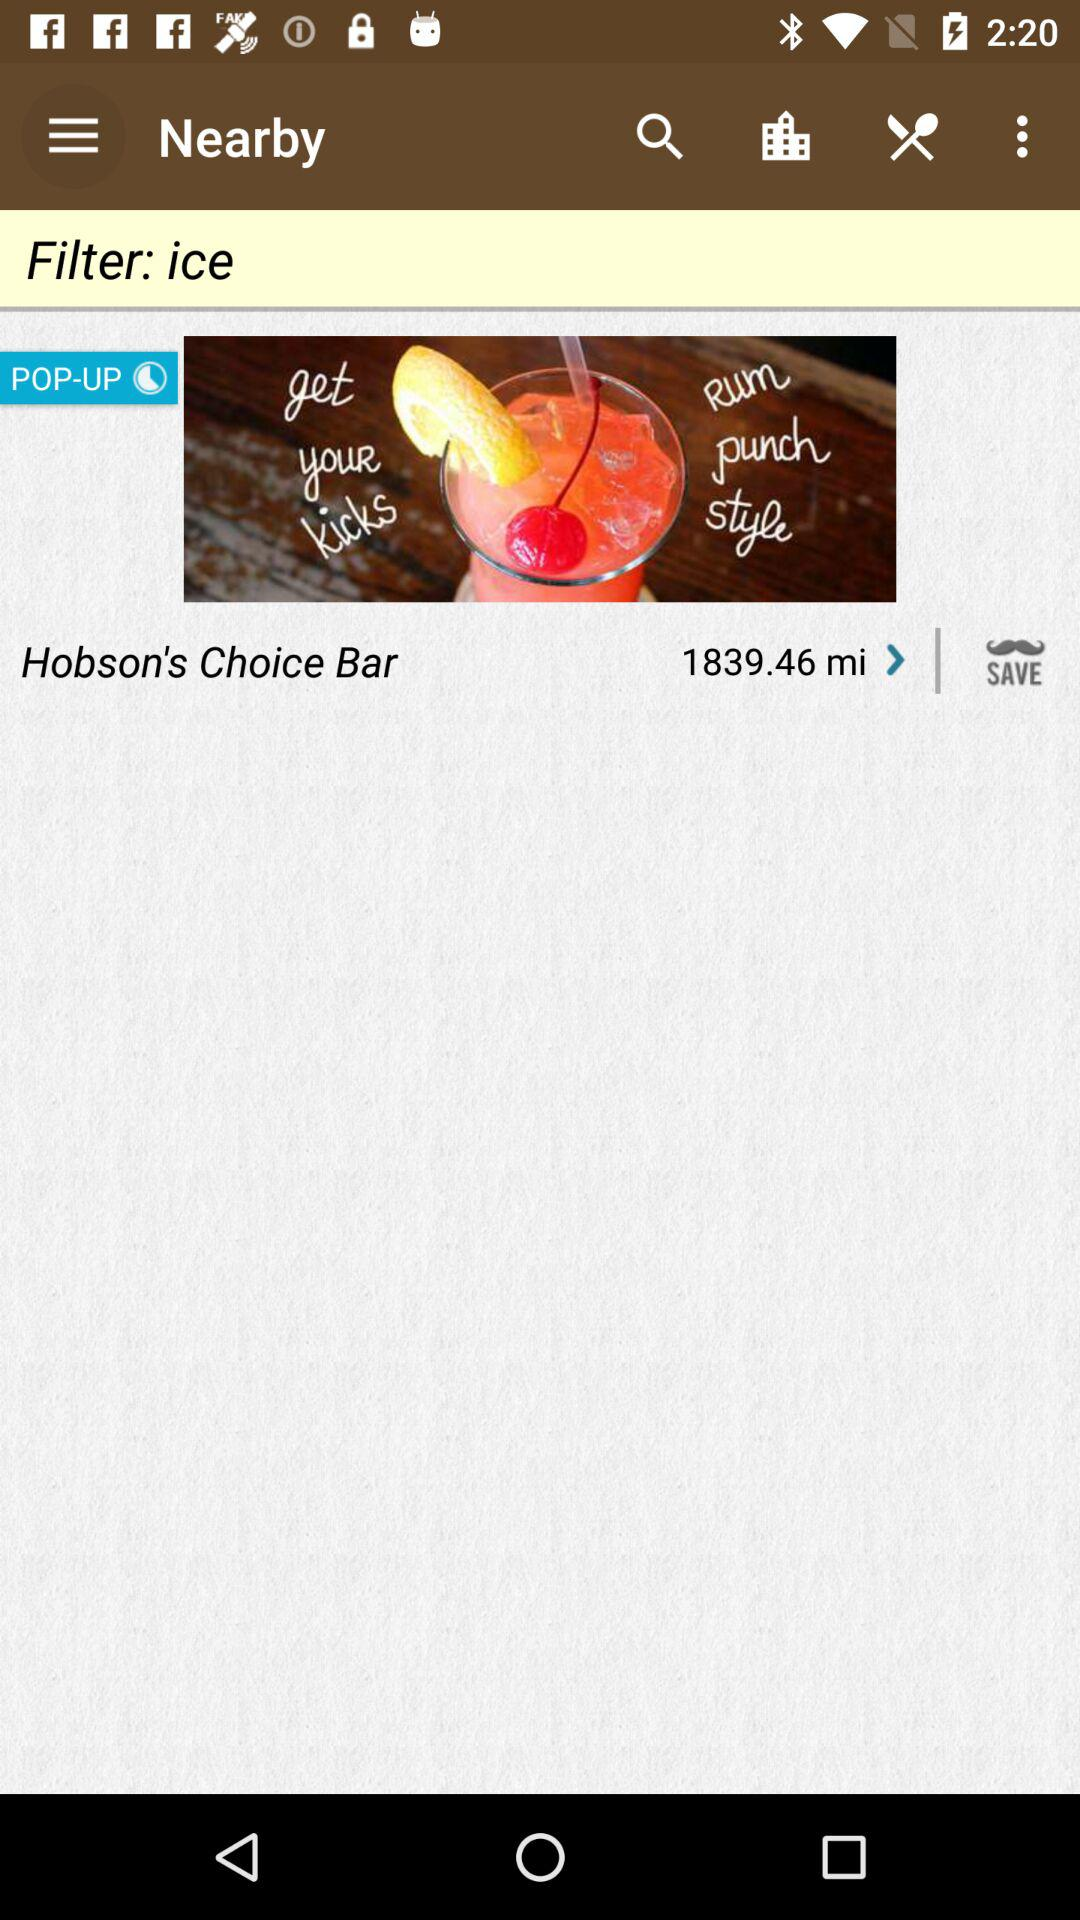How many miles away is Hobson's Choice Bar?
Answer the question using a single word or phrase. 1839.46 mi 